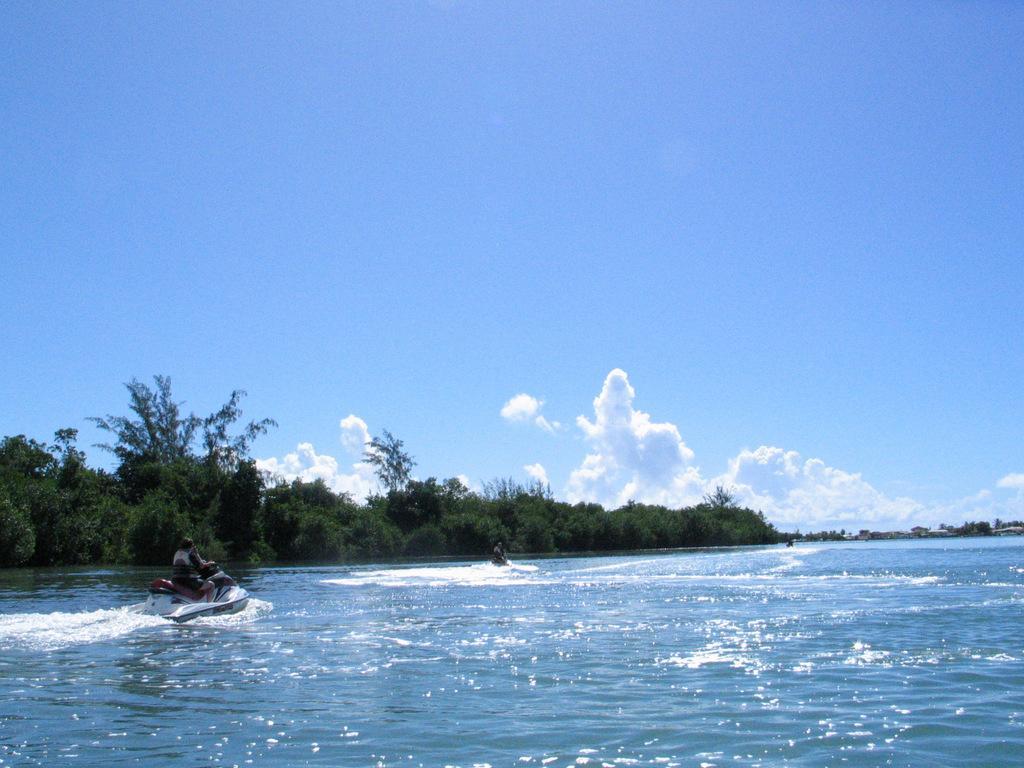How would you summarize this image in a sentence or two? In this image, I can see two people riding water scooters on the water. In front of these people there are trees. In the background, I can see the clouds in the sky. 